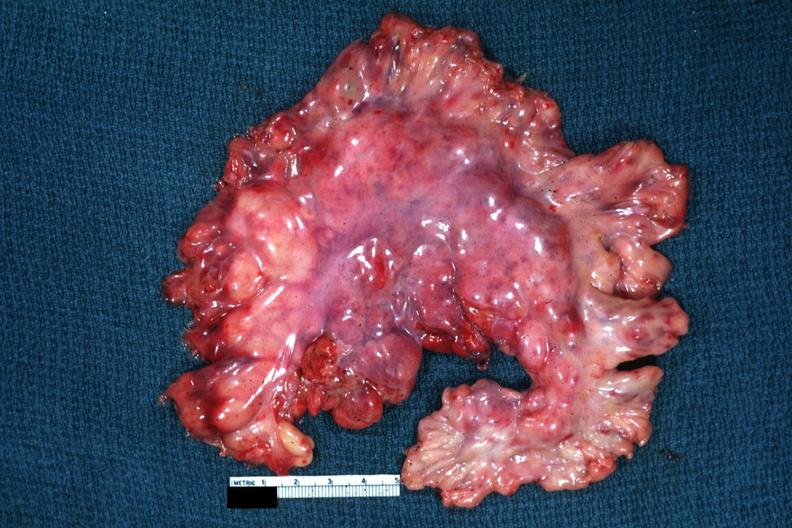what is present?
Answer the question using a single word or phrase. Lymph node 